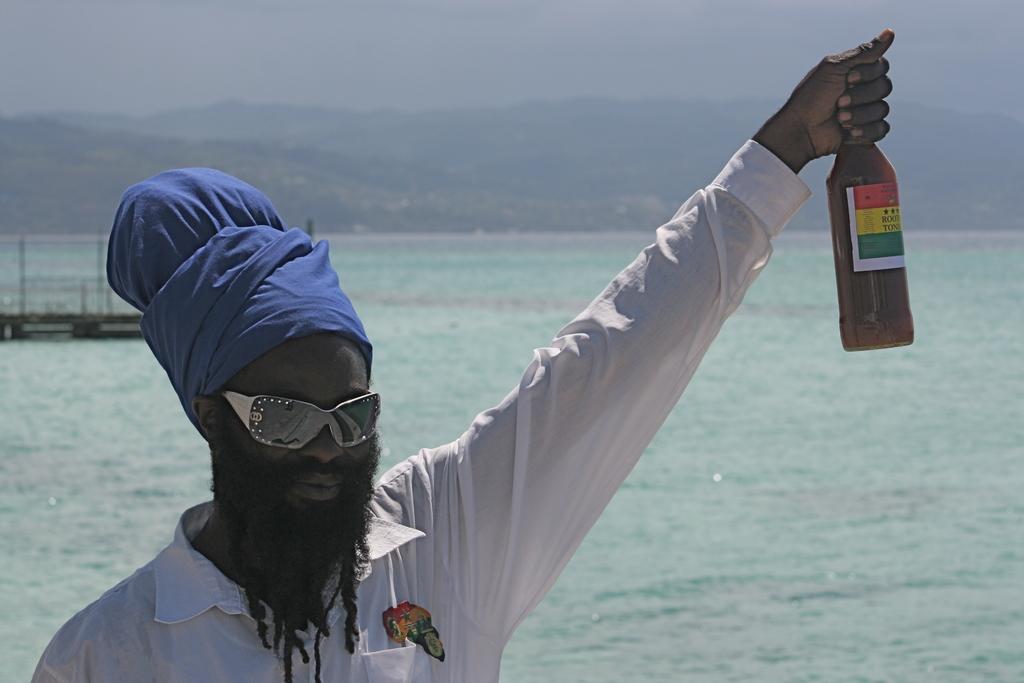How would you summarize this image in a sentence or two? In this picture there is a man who is holding a bottle. There is water at the background. 